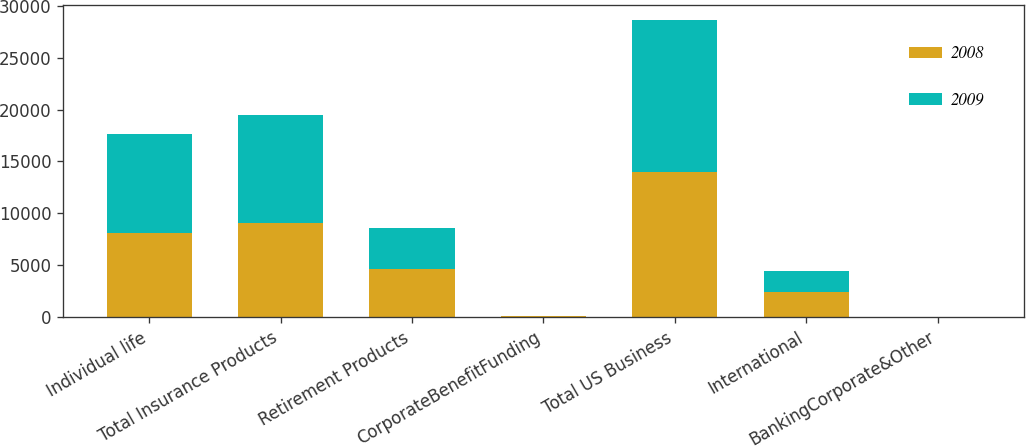Convert chart. <chart><loc_0><loc_0><loc_500><loc_500><stacked_bar_chart><ecel><fcel>Individual life<fcel>Total Insurance Products<fcel>Retirement Products<fcel>CorporateBenefitFunding<fcel>Total US Business<fcel>International<fcel>BankingCorporate&Other<nl><fcel>2008<fcel>8129<fcel>9098<fcel>4611<fcel>73<fcel>13963<fcel>2426<fcel>3<nl><fcel>2009<fcel>9495<fcel>10426<fcel>3971<fcel>72<fcel>14652<fcel>1998<fcel>3<nl></chart> 